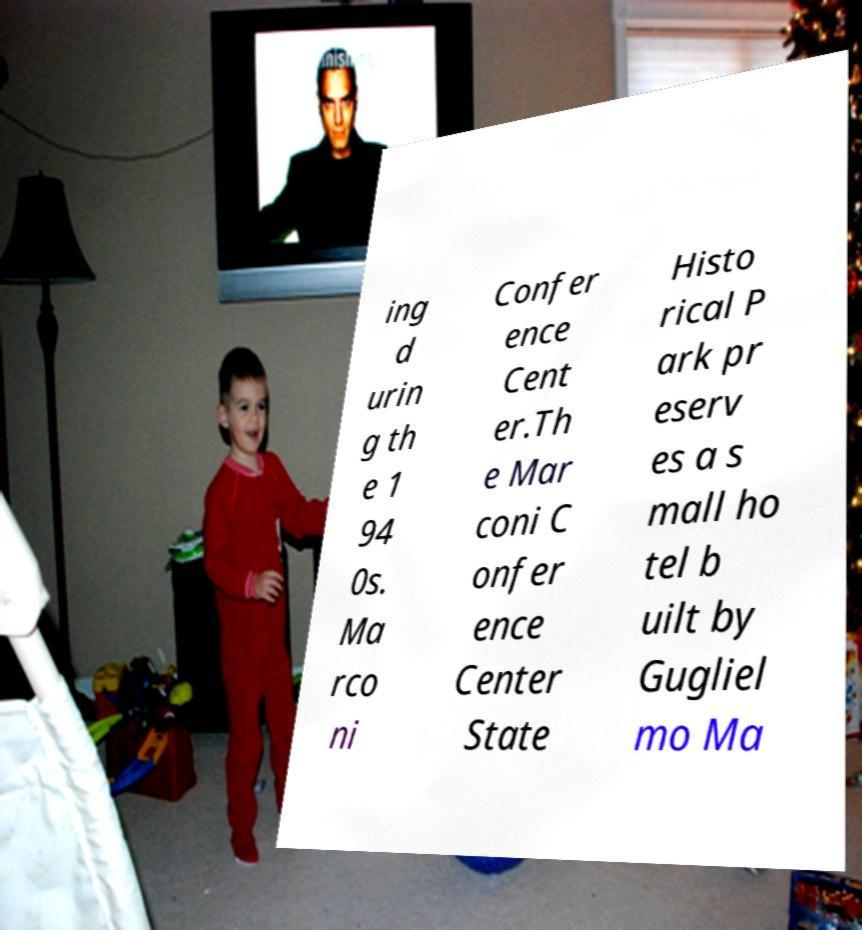I need the written content from this picture converted into text. Can you do that? ing d urin g th e 1 94 0s. Ma rco ni Confer ence Cent er.Th e Mar coni C onfer ence Center State Histo rical P ark pr eserv es a s mall ho tel b uilt by Gugliel mo Ma 